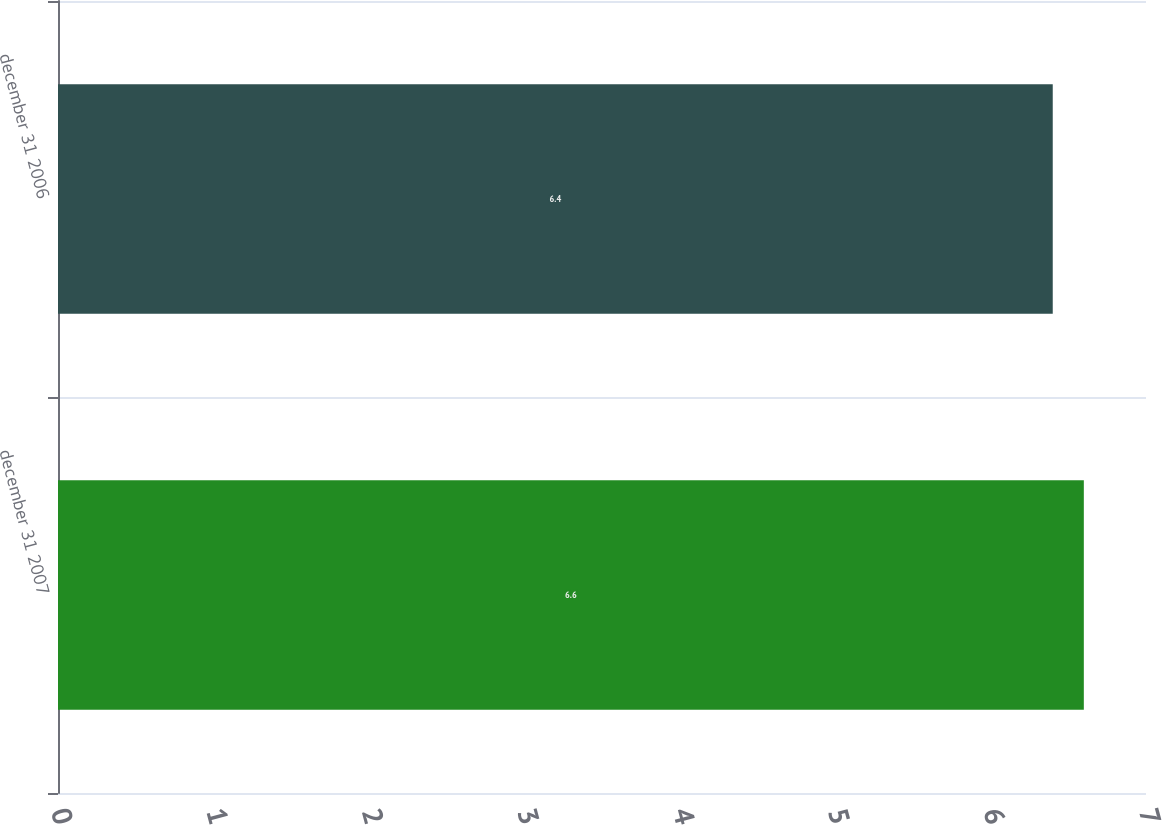Convert chart to OTSL. <chart><loc_0><loc_0><loc_500><loc_500><bar_chart><fcel>december 31 2007<fcel>december 31 2006<nl><fcel>6.6<fcel>6.4<nl></chart> 